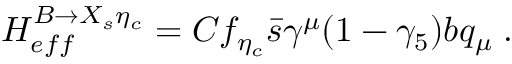<formula> <loc_0><loc_0><loc_500><loc_500>H _ { e f f } ^ { B \to X _ { s } \eta _ { c } } = C f _ { \eta _ { c } } \bar { s } \gamma ^ { \mu } ( 1 - \gamma _ { 5 } ) b q _ { \mu } \, .</formula> 